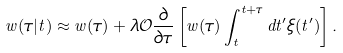Convert formula to latex. <formula><loc_0><loc_0><loc_500><loc_500>w ( \tau | t ) \approx w ( \tau ) + \lambda \mathcal { O } \frac { \partial } { \partial \tau } \left [ w ( \tau ) \int _ { t } ^ { t + \tau } d t ^ { \prime } \xi ( t ^ { \prime } ) \right ] .</formula> 